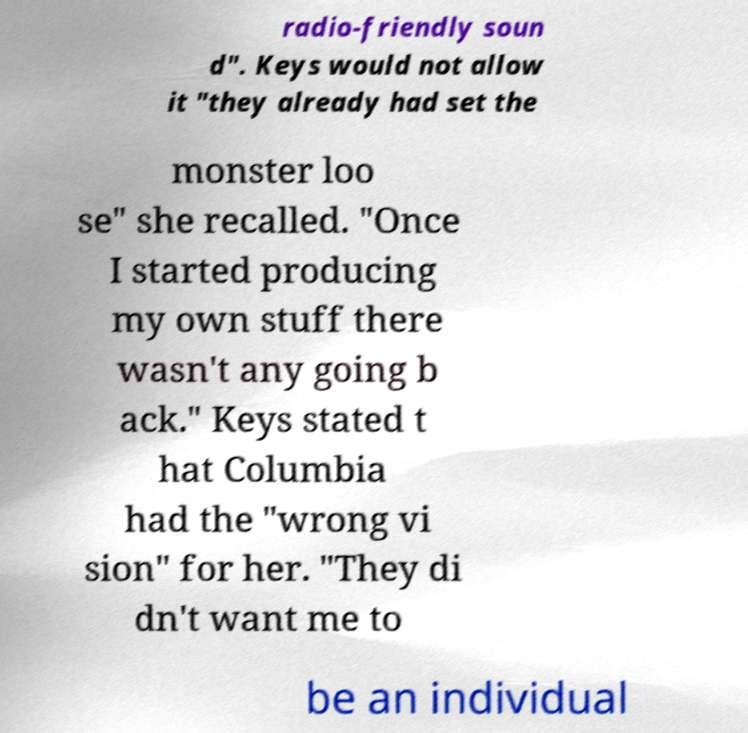Can you accurately transcribe the text from the provided image for me? radio-friendly soun d". Keys would not allow it "they already had set the monster loo se" she recalled. "Once I started producing my own stuff there wasn't any going b ack." Keys stated t hat Columbia had the "wrong vi sion" for her. "They di dn't want me to be an individual 